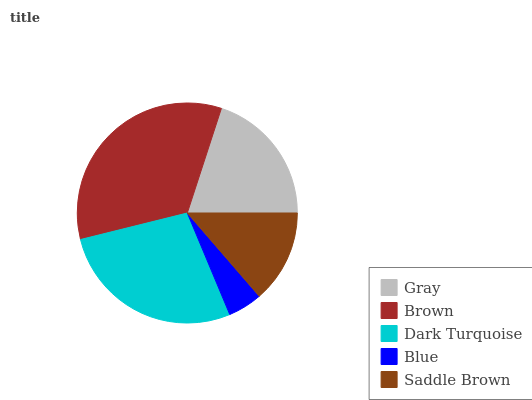Is Blue the minimum?
Answer yes or no. Yes. Is Brown the maximum?
Answer yes or no. Yes. Is Dark Turquoise the minimum?
Answer yes or no. No. Is Dark Turquoise the maximum?
Answer yes or no. No. Is Brown greater than Dark Turquoise?
Answer yes or no. Yes. Is Dark Turquoise less than Brown?
Answer yes or no. Yes. Is Dark Turquoise greater than Brown?
Answer yes or no. No. Is Brown less than Dark Turquoise?
Answer yes or no. No. Is Gray the high median?
Answer yes or no. Yes. Is Gray the low median?
Answer yes or no. Yes. Is Brown the high median?
Answer yes or no. No. Is Saddle Brown the low median?
Answer yes or no. No. 